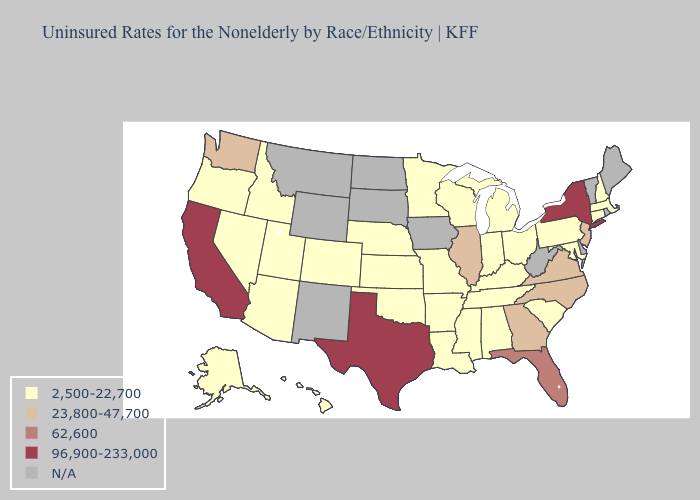Does California have the highest value in the USA?
Write a very short answer. Yes. What is the highest value in states that border Michigan?
Answer briefly. 2,500-22,700. How many symbols are there in the legend?
Write a very short answer. 5. Name the states that have a value in the range 62,600?
Concise answer only. Florida. Among the states that border New Mexico , which have the lowest value?
Write a very short answer. Arizona, Colorado, Oklahoma, Utah. What is the highest value in the USA?
Short answer required. 96,900-233,000. Does North Carolina have the lowest value in the USA?
Keep it brief. No. Name the states that have a value in the range 2,500-22,700?
Keep it brief. Alabama, Alaska, Arizona, Arkansas, Colorado, Connecticut, Hawaii, Idaho, Indiana, Kansas, Kentucky, Louisiana, Maryland, Massachusetts, Michigan, Minnesota, Mississippi, Missouri, Nebraska, Nevada, New Hampshire, Ohio, Oklahoma, Oregon, Pennsylvania, South Carolina, Tennessee, Utah, Wisconsin. What is the value of Michigan?
Quick response, please. 2,500-22,700. Does New York have the highest value in the Northeast?
Give a very brief answer. Yes. Name the states that have a value in the range 23,800-47,700?
Quick response, please. Georgia, Illinois, New Jersey, North Carolina, Virginia, Washington. 